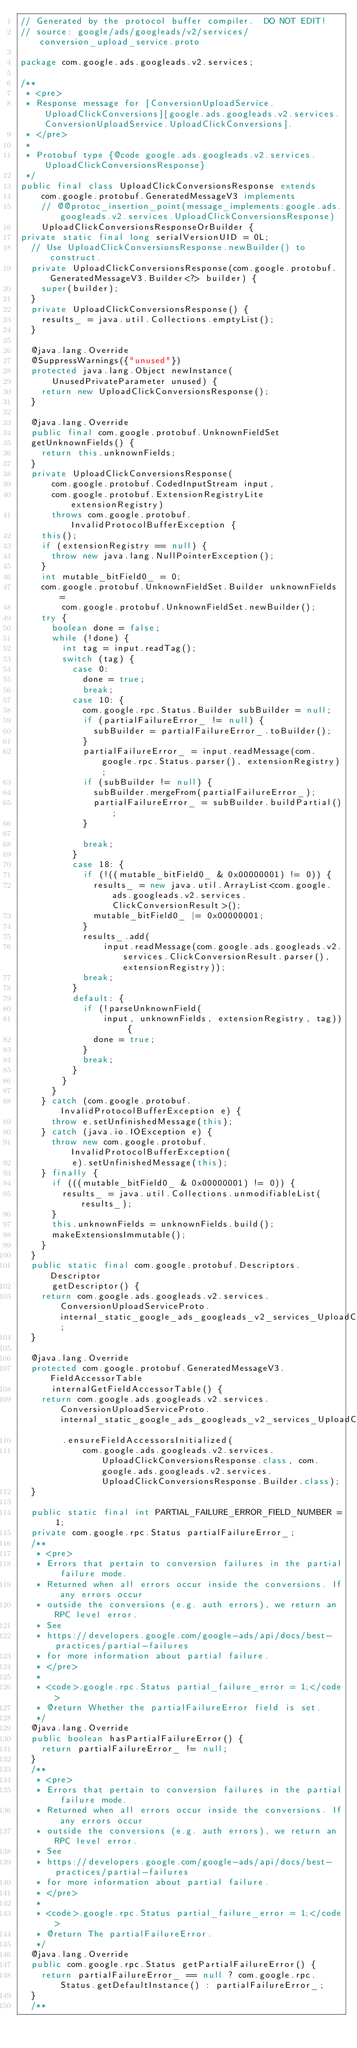Convert code to text. <code><loc_0><loc_0><loc_500><loc_500><_Java_>// Generated by the protocol buffer compiler.  DO NOT EDIT!
// source: google/ads/googleads/v2/services/conversion_upload_service.proto

package com.google.ads.googleads.v2.services;

/**
 * <pre>
 * Response message for [ConversionUploadService.UploadClickConversions][google.ads.googleads.v2.services.ConversionUploadService.UploadClickConversions].
 * </pre>
 *
 * Protobuf type {@code google.ads.googleads.v2.services.UploadClickConversionsResponse}
 */
public final class UploadClickConversionsResponse extends
    com.google.protobuf.GeneratedMessageV3 implements
    // @@protoc_insertion_point(message_implements:google.ads.googleads.v2.services.UploadClickConversionsResponse)
    UploadClickConversionsResponseOrBuilder {
private static final long serialVersionUID = 0L;
  // Use UploadClickConversionsResponse.newBuilder() to construct.
  private UploadClickConversionsResponse(com.google.protobuf.GeneratedMessageV3.Builder<?> builder) {
    super(builder);
  }
  private UploadClickConversionsResponse() {
    results_ = java.util.Collections.emptyList();
  }

  @java.lang.Override
  @SuppressWarnings({"unused"})
  protected java.lang.Object newInstance(
      UnusedPrivateParameter unused) {
    return new UploadClickConversionsResponse();
  }

  @java.lang.Override
  public final com.google.protobuf.UnknownFieldSet
  getUnknownFields() {
    return this.unknownFields;
  }
  private UploadClickConversionsResponse(
      com.google.protobuf.CodedInputStream input,
      com.google.protobuf.ExtensionRegistryLite extensionRegistry)
      throws com.google.protobuf.InvalidProtocolBufferException {
    this();
    if (extensionRegistry == null) {
      throw new java.lang.NullPointerException();
    }
    int mutable_bitField0_ = 0;
    com.google.protobuf.UnknownFieldSet.Builder unknownFields =
        com.google.protobuf.UnknownFieldSet.newBuilder();
    try {
      boolean done = false;
      while (!done) {
        int tag = input.readTag();
        switch (tag) {
          case 0:
            done = true;
            break;
          case 10: {
            com.google.rpc.Status.Builder subBuilder = null;
            if (partialFailureError_ != null) {
              subBuilder = partialFailureError_.toBuilder();
            }
            partialFailureError_ = input.readMessage(com.google.rpc.Status.parser(), extensionRegistry);
            if (subBuilder != null) {
              subBuilder.mergeFrom(partialFailureError_);
              partialFailureError_ = subBuilder.buildPartial();
            }

            break;
          }
          case 18: {
            if (!((mutable_bitField0_ & 0x00000001) != 0)) {
              results_ = new java.util.ArrayList<com.google.ads.googleads.v2.services.ClickConversionResult>();
              mutable_bitField0_ |= 0x00000001;
            }
            results_.add(
                input.readMessage(com.google.ads.googleads.v2.services.ClickConversionResult.parser(), extensionRegistry));
            break;
          }
          default: {
            if (!parseUnknownField(
                input, unknownFields, extensionRegistry, tag)) {
              done = true;
            }
            break;
          }
        }
      }
    } catch (com.google.protobuf.InvalidProtocolBufferException e) {
      throw e.setUnfinishedMessage(this);
    } catch (java.io.IOException e) {
      throw new com.google.protobuf.InvalidProtocolBufferException(
          e).setUnfinishedMessage(this);
    } finally {
      if (((mutable_bitField0_ & 0x00000001) != 0)) {
        results_ = java.util.Collections.unmodifiableList(results_);
      }
      this.unknownFields = unknownFields.build();
      makeExtensionsImmutable();
    }
  }
  public static final com.google.protobuf.Descriptors.Descriptor
      getDescriptor() {
    return com.google.ads.googleads.v2.services.ConversionUploadServiceProto.internal_static_google_ads_googleads_v2_services_UploadClickConversionsResponse_descriptor;
  }

  @java.lang.Override
  protected com.google.protobuf.GeneratedMessageV3.FieldAccessorTable
      internalGetFieldAccessorTable() {
    return com.google.ads.googleads.v2.services.ConversionUploadServiceProto.internal_static_google_ads_googleads_v2_services_UploadClickConversionsResponse_fieldAccessorTable
        .ensureFieldAccessorsInitialized(
            com.google.ads.googleads.v2.services.UploadClickConversionsResponse.class, com.google.ads.googleads.v2.services.UploadClickConversionsResponse.Builder.class);
  }

  public static final int PARTIAL_FAILURE_ERROR_FIELD_NUMBER = 1;
  private com.google.rpc.Status partialFailureError_;
  /**
   * <pre>
   * Errors that pertain to conversion failures in the partial failure mode.
   * Returned when all errors occur inside the conversions. If any errors occur
   * outside the conversions (e.g. auth errors), we return an RPC level error.
   * See
   * https://developers.google.com/google-ads/api/docs/best-practices/partial-failures
   * for more information about partial failure.
   * </pre>
   *
   * <code>.google.rpc.Status partial_failure_error = 1;</code>
   * @return Whether the partialFailureError field is set.
   */
  @java.lang.Override
  public boolean hasPartialFailureError() {
    return partialFailureError_ != null;
  }
  /**
   * <pre>
   * Errors that pertain to conversion failures in the partial failure mode.
   * Returned when all errors occur inside the conversions. If any errors occur
   * outside the conversions (e.g. auth errors), we return an RPC level error.
   * See
   * https://developers.google.com/google-ads/api/docs/best-practices/partial-failures
   * for more information about partial failure.
   * </pre>
   *
   * <code>.google.rpc.Status partial_failure_error = 1;</code>
   * @return The partialFailureError.
   */
  @java.lang.Override
  public com.google.rpc.Status getPartialFailureError() {
    return partialFailureError_ == null ? com.google.rpc.Status.getDefaultInstance() : partialFailureError_;
  }
  /**</code> 